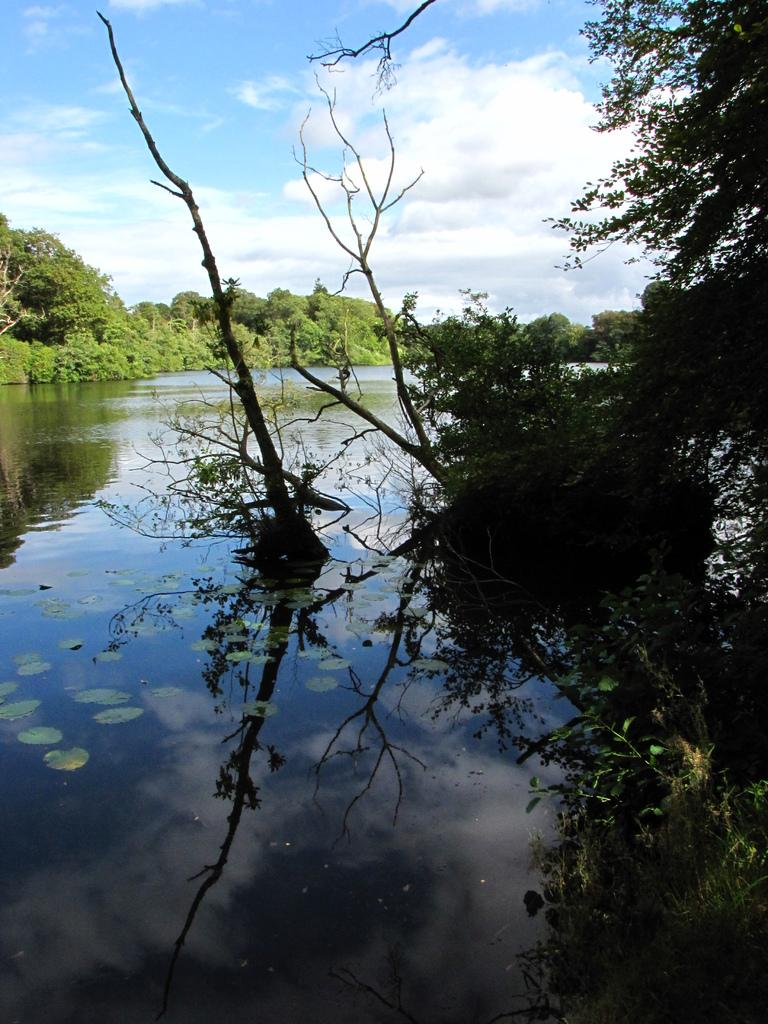What type of plants can be seen in the image? There are plants in the water in the image. What other types of vegetation can be seen in the image? There are plants and trees in the background of the image. What is visible at the top of the image? The sky is visible at the top of the image. What material is the trunk in the water made of? The wooden trunk in the water is made of wood. What type of writing can be seen on the bridge in the image? There is no bridge present in the image, so there is no writing on a bridge to observe. 